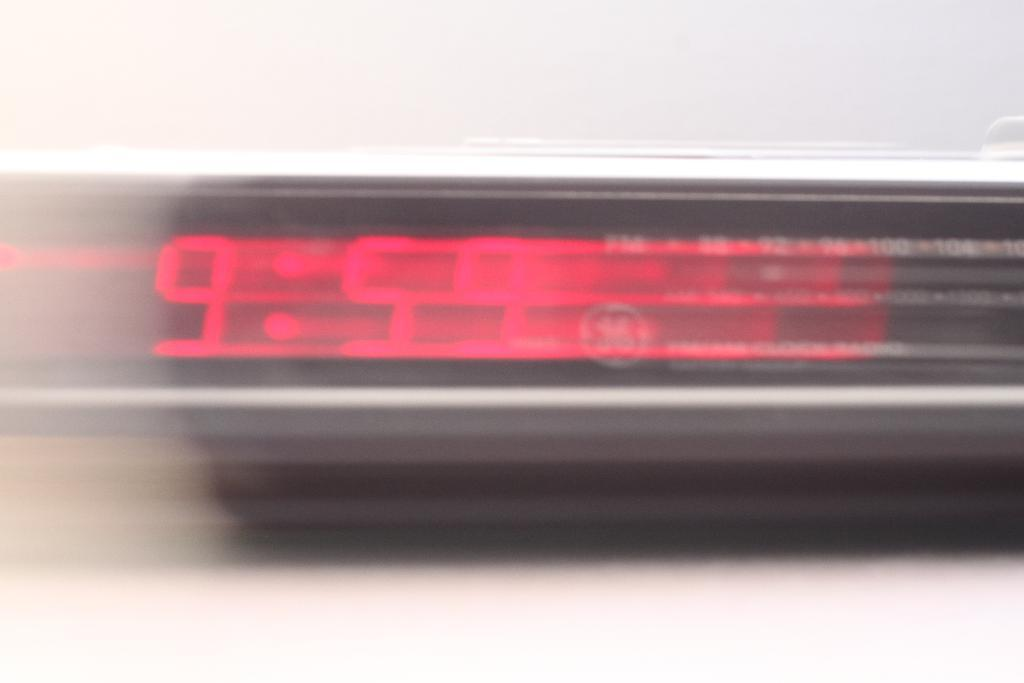What type of clock is visible in the image? There is a digital clock in the image. What information is displayed on the digital clock? The digital clock is displaying the time. What is the background of the image? There is a wall at the top of the image. Can you see any cars in the image? There are no cars present in the image. What type of friction is occurring between the clock and the wall in the image? There is no friction mentioned or visible in the image; it is a digital clock mounted on a wall. 